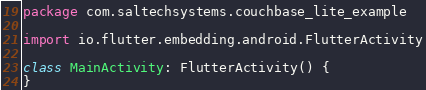<code> <loc_0><loc_0><loc_500><loc_500><_Kotlin_>package com.saltechsystems.couchbase_lite_example

import io.flutter.embedding.android.FlutterActivity

class MainActivity: FlutterActivity() {
}
</code> 